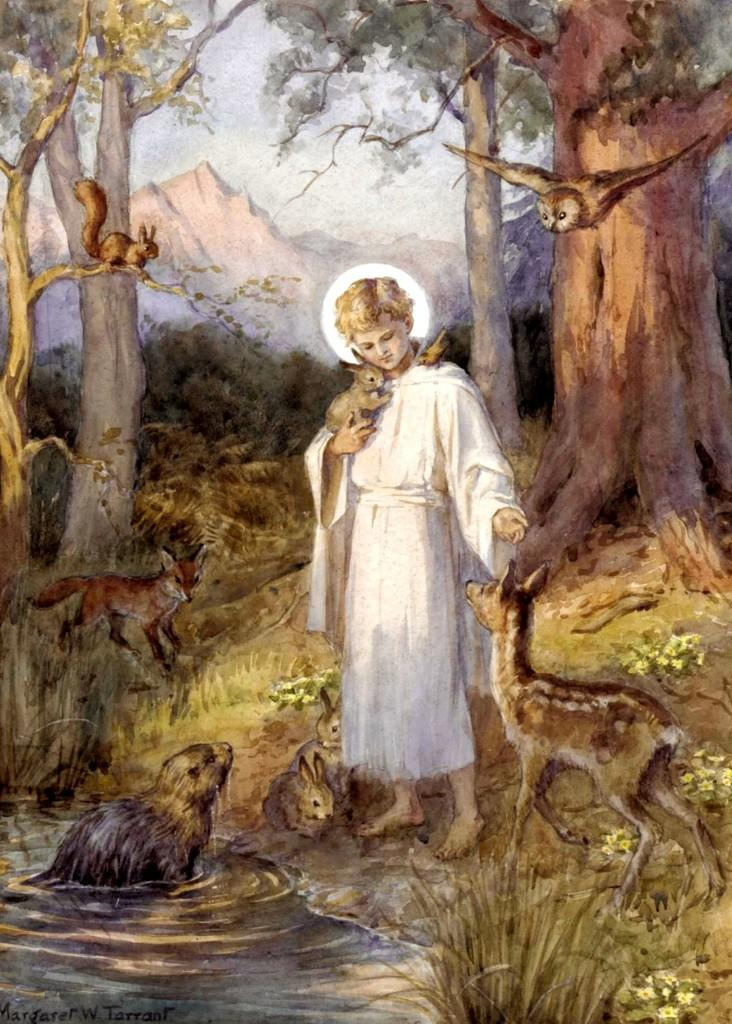What type of artwork is depicted in the image? The image is a painting. Can you describe the person in the painting? There is a person standing in the painting, and they are holding a rabbit. What other animal can be seen in the painting? There is a calf on the right side of the painting. What can be seen in the background of the painting? There are trees in the background of the painting. What type of church can be seen in the painting? There is no church present in the painting; it features a person holding a rabbit, a calf, and trees in the background. What is the texture of the bears in the painting? There are no bears present in the painting, so it is not possible to determine their texture. 